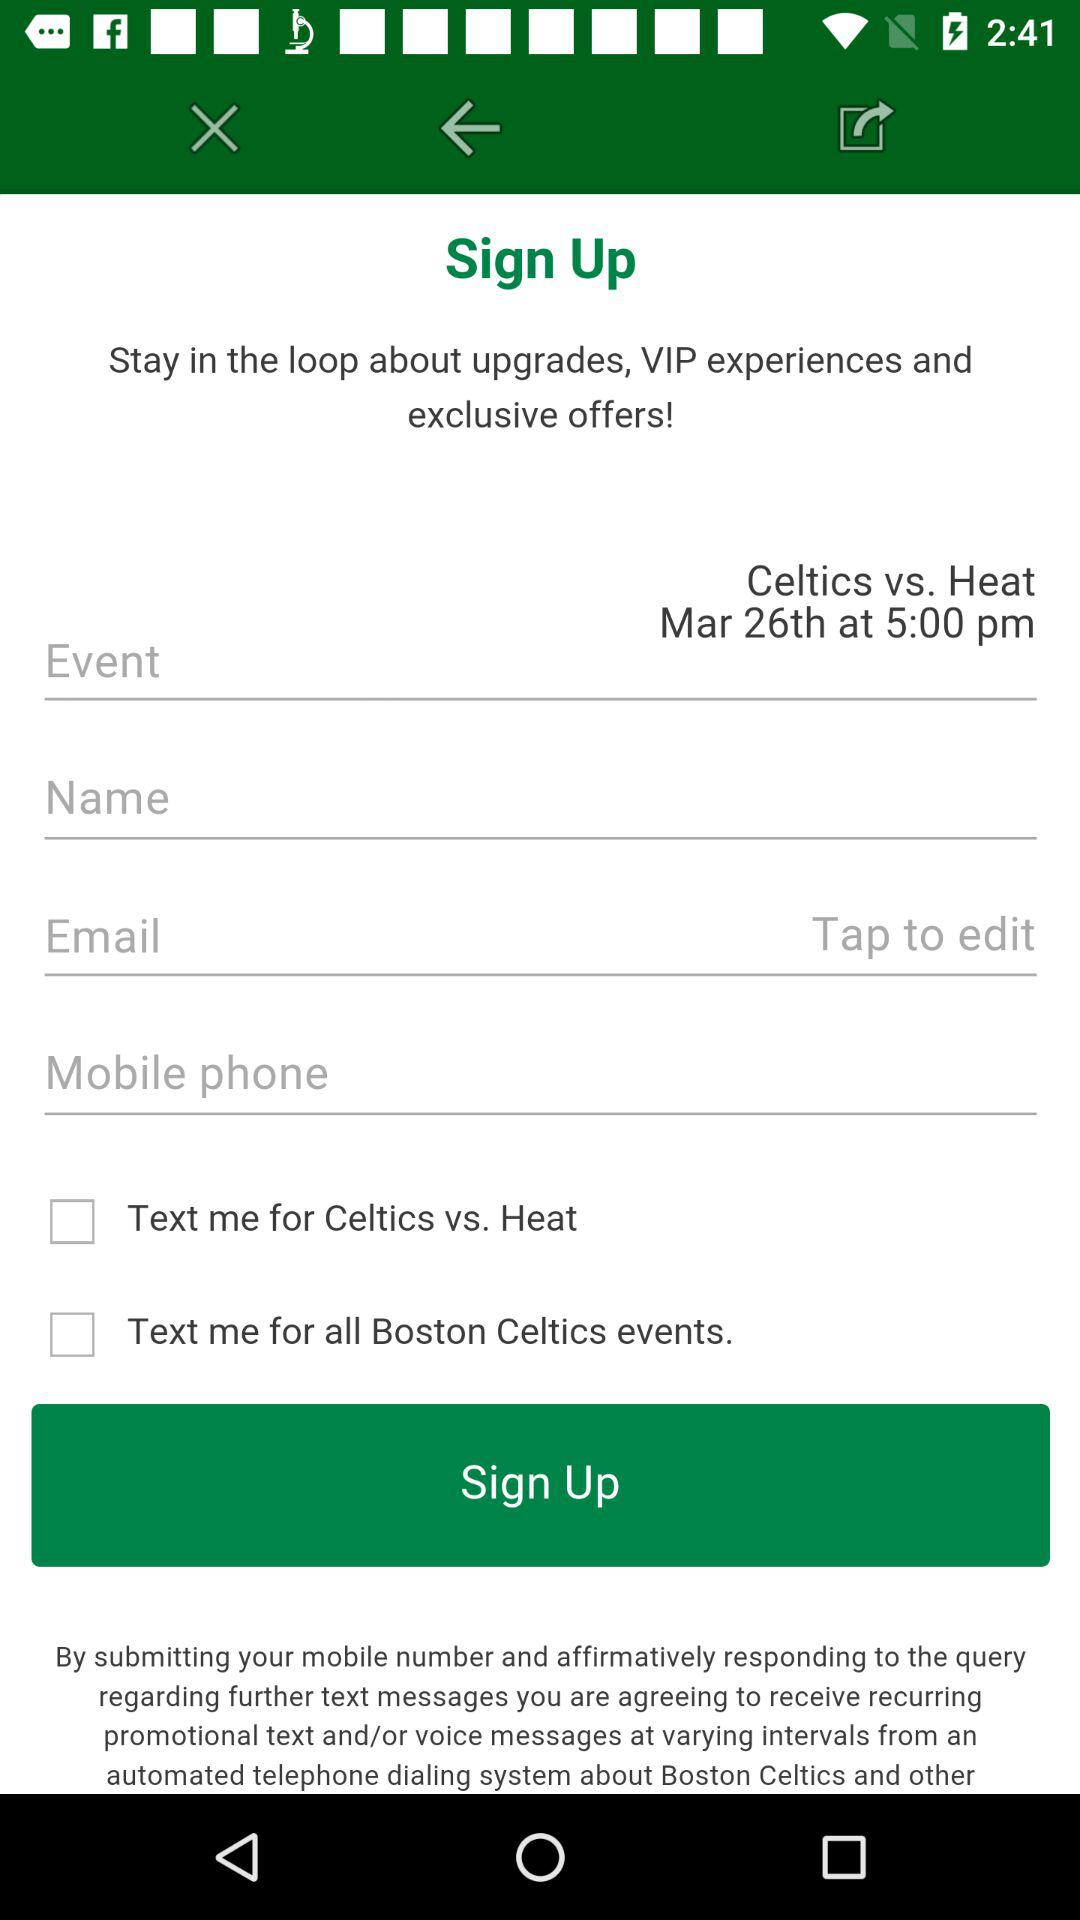How many checkboxes are on the screen?
Answer the question using a single word or phrase. 2 